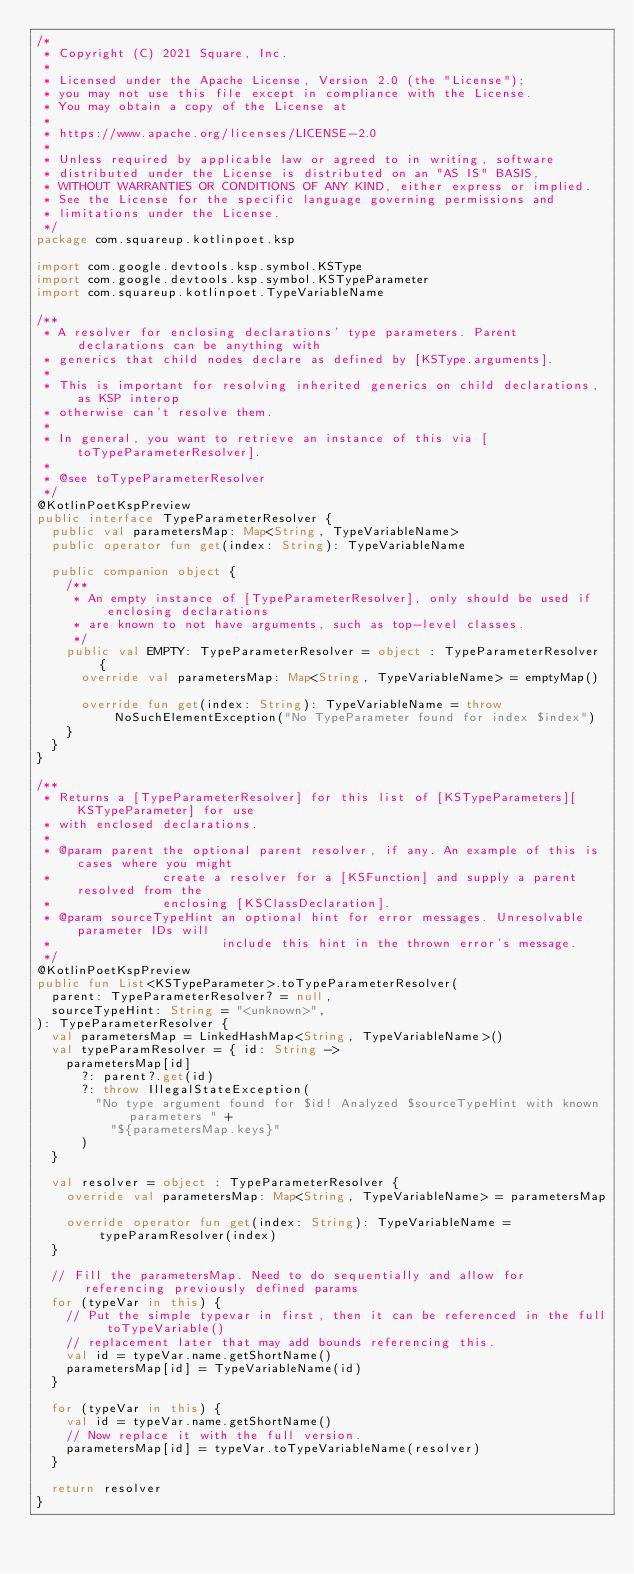<code> <loc_0><loc_0><loc_500><loc_500><_Kotlin_>/*
 * Copyright (C) 2021 Square, Inc.
 *
 * Licensed under the Apache License, Version 2.0 (the "License");
 * you may not use this file except in compliance with the License.
 * You may obtain a copy of the License at
 *
 * https://www.apache.org/licenses/LICENSE-2.0
 *
 * Unless required by applicable law or agreed to in writing, software
 * distributed under the License is distributed on an "AS IS" BASIS,
 * WITHOUT WARRANTIES OR CONDITIONS OF ANY KIND, either express or implied.
 * See the License for the specific language governing permissions and
 * limitations under the License.
 */
package com.squareup.kotlinpoet.ksp

import com.google.devtools.ksp.symbol.KSType
import com.google.devtools.ksp.symbol.KSTypeParameter
import com.squareup.kotlinpoet.TypeVariableName

/**
 * A resolver for enclosing declarations' type parameters. Parent declarations can be anything with
 * generics that child nodes declare as defined by [KSType.arguments].
 *
 * This is important for resolving inherited generics on child declarations, as KSP interop
 * otherwise can't resolve them.
 *
 * In general, you want to retrieve an instance of this via [toTypeParameterResolver].
 *
 * @see toTypeParameterResolver
 */
@KotlinPoetKspPreview
public interface TypeParameterResolver {
  public val parametersMap: Map<String, TypeVariableName>
  public operator fun get(index: String): TypeVariableName

  public companion object {
    /**
     * An empty instance of [TypeParameterResolver], only should be used if enclosing declarations
     * are known to not have arguments, such as top-level classes.
     */
    public val EMPTY: TypeParameterResolver = object : TypeParameterResolver {
      override val parametersMap: Map<String, TypeVariableName> = emptyMap()

      override fun get(index: String): TypeVariableName = throw NoSuchElementException("No TypeParameter found for index $index")
    }
  }
}

/**
 * Returns a [TypeParameterResolver] for this list of [KSTypeParameters][KSTypeParameter] for use
 * with enclosed declarations.
 *
 * @param parent the optional parent resolver, if any. An example of this is cases where you might
 *               create a resolver for a [KSFunction] and supply a parent resolved from the
 *               enclosing [KSClassDeclaration].
 * @param sourceTypeHint an optional hint for error messages. Unresolvable parameter IDs will
 *                       include this hint in the thrown error's message.
 */
@KotlinPoetKspPreview
public fun List<KSTypeParameter>.toTypeParameterResolver(
  parent: TypeParameterResolver? = null,
  sourceTypeHint: String = "<unknown>",
): TypeParameterResolver {
  val parametersMap = LinkedHashMap<String, TypeVariableName>()
  val typeParamResolver = { id: String ->
    parametersMap[id]
      ?: parent?.get(id)
      ?: throw IllegalStateException(
        "No type argument found for $id! Analyzed $sourceTypeHint with known parameters " +
          "${parametersMap.keys}"
      )
  }

  val resolver = object : TypeParameterResolver {
    override val parametersMap: Map<String, TypeVariableName> = parametersMap

    override operator fun get(index: String): TypeVariableName = typeParamResolver(index)
  }

  // Fill the parametersMap. Need to do sequentially and allow for referencing previously defined params
  for (typeVar in this) {
    // Put the simple typevar in first, then it can be referenced in the full toTypeVariable()
    // replacement later that may add bounds referencing this.
    val id = typeVar.name.getShortName()
    parametersMap[id] = TypeVariableName(id)
  }

  for (typeVar in this) {
    val id = typeVar.name.getShortName()
    // Now replace it with the full version.
    parametersMap[id] = typeVar.toTypeVariableName(resolver)
  }

  return resolver
}
</code> 